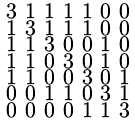Convert formula to latex. <formula><loc_0><loc_0><loc_500><loc_500>\begin{smallmatrix} 3 & 1 & 1 & 1 & 1 & 0 & 0 \\ 1 & 3 & 1 & 1 & 1 & 0 & 0 \\ 1 & 1 & 3 & 0 & 0 & 1 & 0 \\ 1 & 1 & 0 & 3 & 0 & 1 & 0 \\ 1 & 1 & 0 & 0 & 3 & 0 & 1 \\ 0 & 0 & 1 & 1 & 0 & 3 & 1 \\ 0 & 0 & 0 & 0 & 1 & 1 & 3 \end{smallmatrix}</formula> 